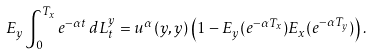<formula> <loc_0><loc_0><loc_500><loc_500>E _ { y } \int _ { 0 } ^ { T _ { x } } e ^ { - \alpha t } \, d L ^ { y } _ { t } = u ^ { \alpha } ( y , y ) \left ( 1 - E _ { y } ( e ^ { - \alpha T _ { x } } ) E _ { x } ( e ^ { - \alpha T _ { y } } ) \right ) .</formula> 